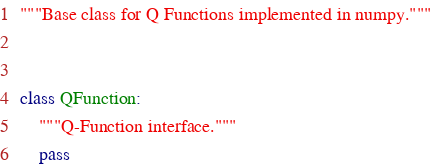Convert code to text. <code><loc_0><loc_0><loc_500><loc_500><_Python_>"""Base class for Q Functions implemented in numpy."""


class QFunction:
    """Q-Function interface."""
    pass
</code> 